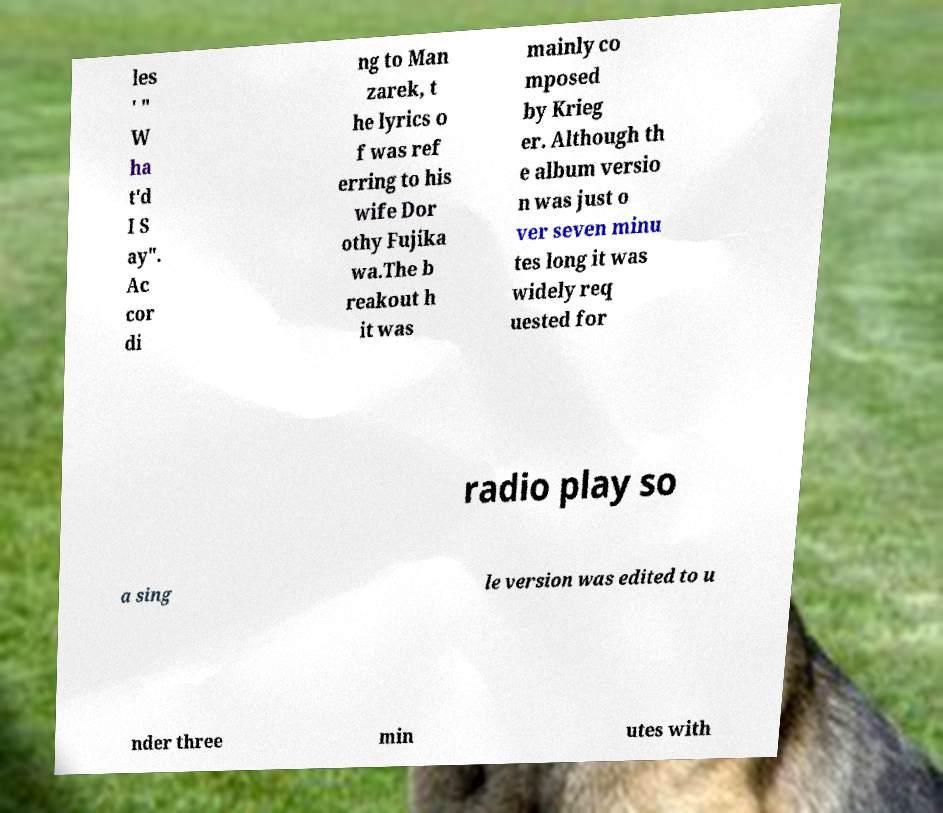Please read and relay the text visible in this image. What does it say? les ' " W ha t'd I S ay". Ac cor di ng to Man zarek, t he lyrics o f was ref erring to his wife Dor othy Fujika wa.The b reakout h it was mainly co mposed by Krieg er. Although th e album versio n was just o ver seven minu tes long it was widely req uested for radio play so a sing le version was edited to u nder three min utes with 